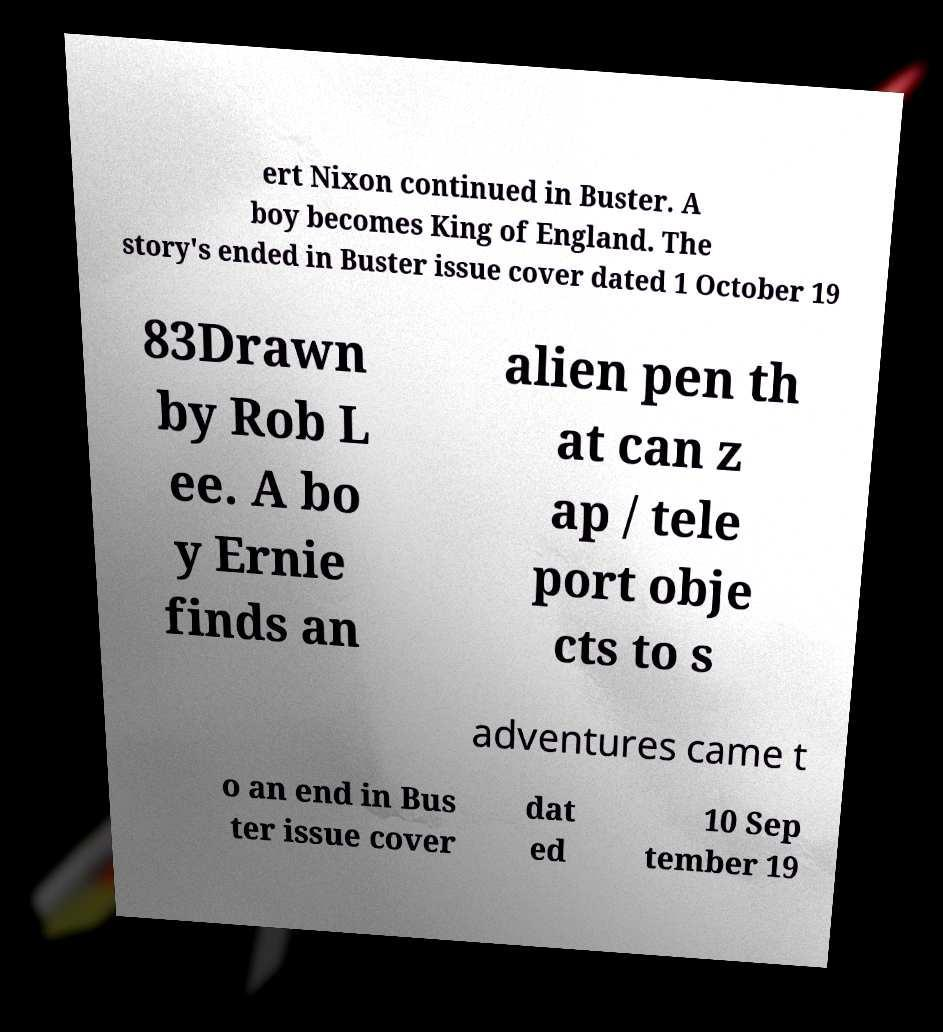Can you read and provide the text displayed in the image?This photo seems to have some interesting text. Can you extract and type it out for me? ert Nixon continued in Buster. A boy becomes King of England. The story's ended in Buster issue cover dated 1 October 19 83Drawn by Rob L ee. A bo y Ernie finds an alien pen th at can z ap / tele port obje cts to s adventures came t o an end in Bus ter issue cover dat ed 10 Sep tember 19 